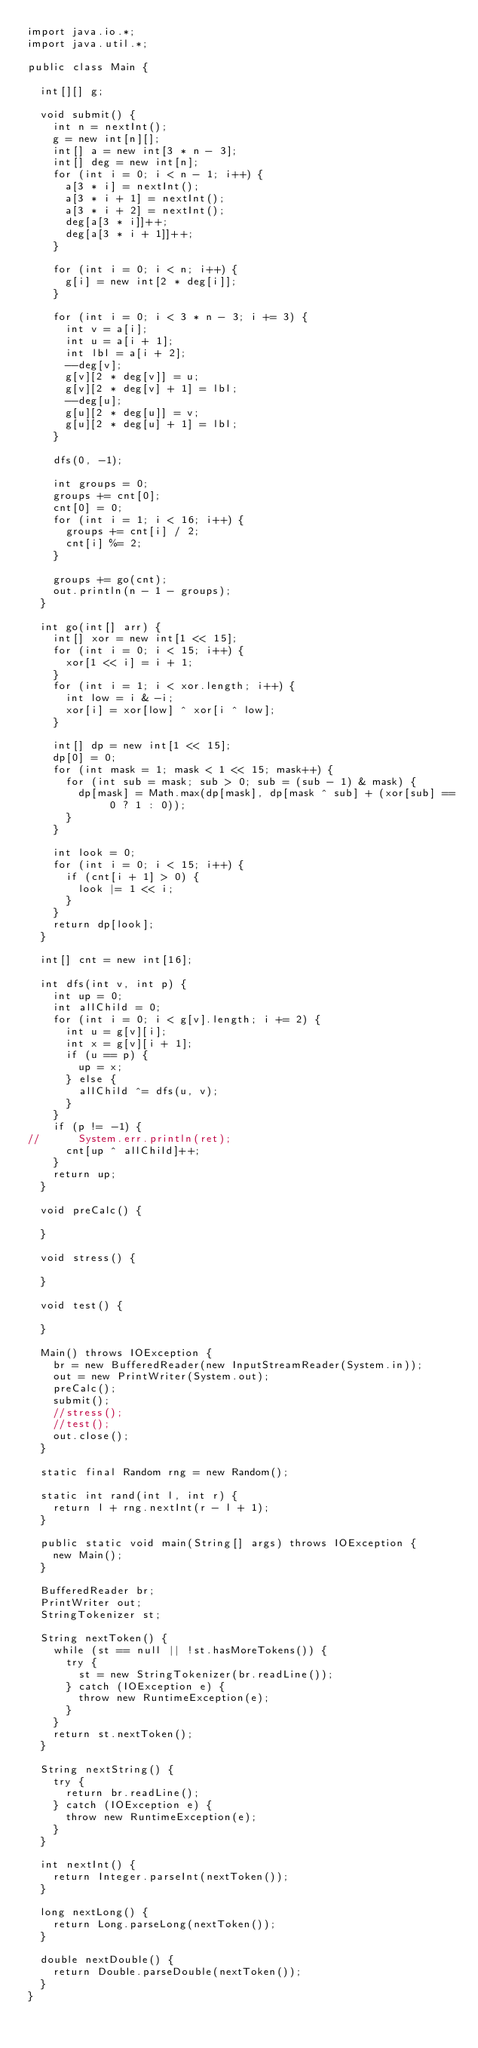Convert code to text. <code><loc_0><loc_0><loc_500><loc_500><_Java_>import java.io.*;
import java.util.*;

public class Main {
	
	int[][] g;

	void submit() {
		int n = nextInt();
		g = new int[n][];
		int[] a = new int[3 * n - 3];
		int[] deg = new int[n];
		for (int i = 0; i < n - 1; i++) {
			a[3 * i] = nextInt();
			a[3 * i + 1] = nextInt();
			a[3 * i + 2] = nextInt();
			deg[a[3 * i]]++;
			deg[a[3 * i + 1]]++;
		}

		for (int i = 0; i < n; i++) {
			g[i] = new int[2 * deg[i]];
		}

		for (int i = 0; i < 3 * n - 3; i += 3) {
			int v = a[i];
			int u = a[i + 1];
			int lbl = a[i + 2];
			--deg[v];
			g[v][2 * deg[v]] = u;
			g[v][2 * deg[v] + 1] = lbl;
			--deg[u];
			g[u][2 * deg[u]] = v;
			g[u][2 * deg[u] + 1] = lbl;
		}
		
		dfs(0, -1);
		
		int groups = 0;
		groups += cnt[0];
		cnt[0] = 0;
		for (int i = 1; i < 16; i++) {
			groups += cnt[i] / 2;
			cnt[i] %= 2;
		}
		
		groups += go(cnt);
		out.println(n - 1 - groups);
	}
	
	int go(int[] arr) {
		int[] xor = new int[1 << 15];
		for (int i = 0; i < 15; i++) {
			xor[1 << i] = i + 1;
		}
		for (int i = 1; i < xor.length; i++) {
			int low = i & -i;
			xor[i] = xor[low] ^ xor[i ^ low];
		}
		
		int[] dp = new int[1 << 15];
		dp[0] = 0;
		for (int mask = 1; mask < 1 << 15; mask++) {
			for (int sub = mask; sub > 0; sub = (sub - 1) & mask) {
				dp[mask] = Math.max(dp[mask], dp[mask ^ sub] + (xor[sub] == 0 ? 1 : 0));
			}
		}
		
		int look = 0;
		for (int i = 0; i < 15; i++) {
			if (cnt[i + 1] > 0) {
				look |= 1 << i;
			}
		}
		return dp[look];
	}
	
	int[] cnt = new int[16];
	
	int dfs(int v, int p) {
		int up = 0;
		int allChild = 0;
		for (int i = 0; i < g[v].length; i += 2) {
			int u = g[v][i];
			int x = g[v][i + 1];
			if (u == p) {
				up = x;
			} else {
				allChild ^= dfs(u, v);
			}
		}
		if (p != -1) {
//			System.err.println(ret);
			cnt[up ^ allChild]++;
		}
		return up;
	}

	void preCalc() {

	}

	void stress() {

	}

	void test() {

	}

	Main() throws IOException {
		br = new BufferedReader(new InputStreamReader(System.in));
		out = new PrintWriter(System.out);
		preCalc();
		submit();
		//stress();
		//test();
		out.close();
	}

	static final Random rng = new Random();

	static int rand(int l, int r) {
		return l + rng.nextInt(r - l + 1);
	}

	public static void main(String[] args) throws IOException {
		new Main();
	}

	BufferedReader br;
	PrintWriter out;
	StringTokenizer st;

	String nextToken() {
		while (st == null || !st.hasMoreTokens()) {
			try {
				st = new StringTokenizer(br.readLine());
			} catch (IOException e) {
				throw new RuntimeException(e);
			}
		}
		return st.nextToken();
	}

	String nextString() {
		try {
			return br.readLine();
		} catch (IOException e) {
			throw new RuntimeException(e);
		}
	}

	int nextInt() {
		return Integer.parseInt(nextToken());
	}

	long nextLong() {
		return Long.parseLong(nextToken());
	}

	double nextDouble() {
		return Double.parseDouble(nextToken());
	}
}
</code> 